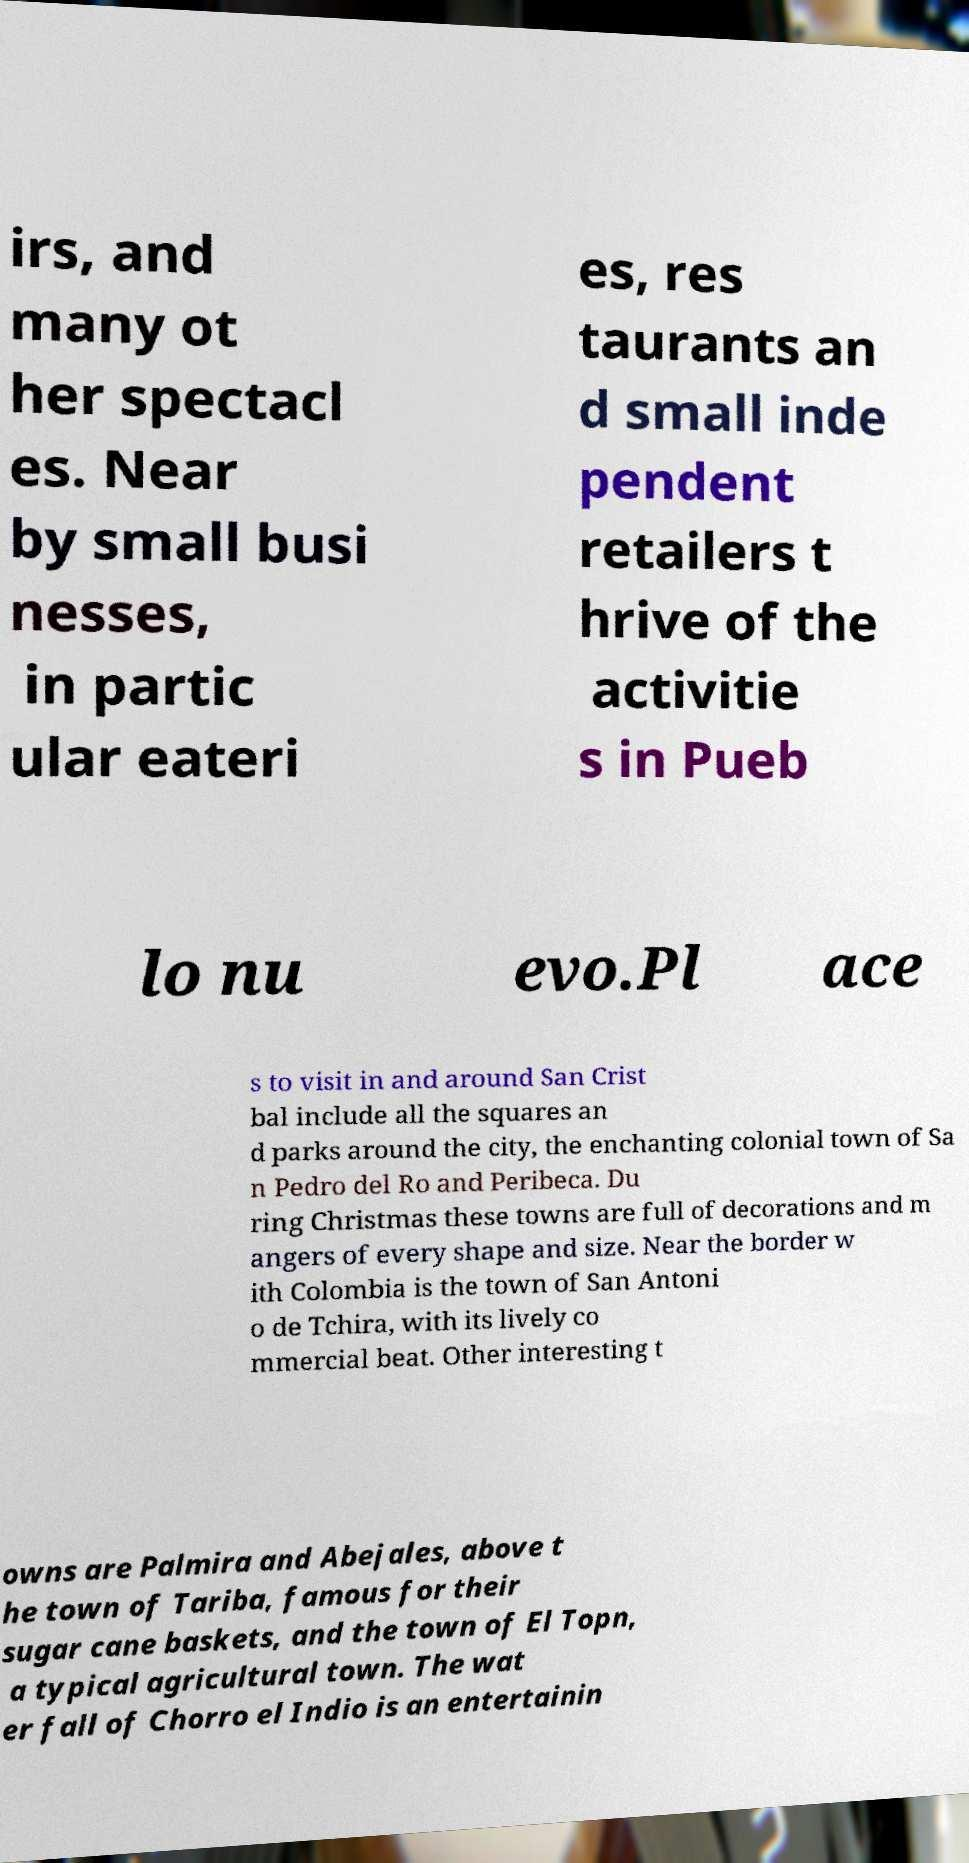For documentation purposes, I need the text within this image transcribed. Could you provide that? irs, and many ot her spectacl es. Near by small busi nesses, in partic ular eateri es, res taurants an d small inde pendent retailers t hrive of the activitie s in Pueb lo nu evo.Pl ace s to visit in and around San Crist bal include all the squares an d parks around the city, the enchanting colonial town of Sa n Pedro del Ro and Peribeca. Du ring Christmas these towns are full of decorations and m angers of every shape and size. Near the border w ith Colombia is the town of San Antoni o de Tchira, with its lively co mmercial beat. Other interesting t owns are Palmira and Abejales, above t he town of Tariba, famous for their sugar cane baskets, and the town of El Topn, a typical agricultural town. The wat er fall of Chorro el Indio is an entertainin 